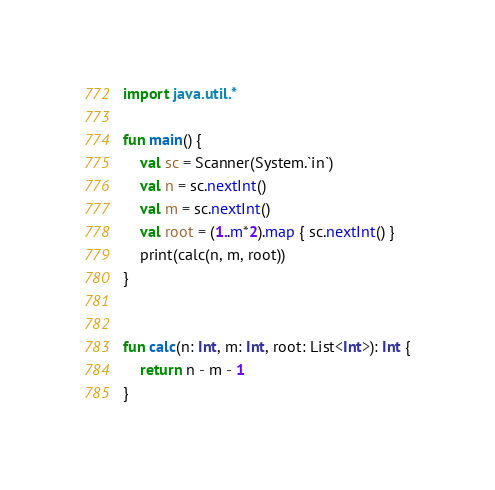<code> <loc_0><loc_0><loc_500><loc_500><_Kotlin_>import java.util.*

fun main() {
    val sc = Scanner(System.`in`)
    val n = sc.nextInt()
    val m = sc.nextInt()
    val root = (1..m*2).map { sc.nextInt() }
    print(calc(n, m, root))
}


fun calc(n: Int, m: Int, root: List<Int>): Int {
    return n - m - 1
}
</code> 